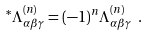Convert formula to latex. <formula><loc_0><loc_0><loc_500><loc_500>^ { * } { \Lambda } _ { { \alpha } { \beta } { \gamma } } ^ { ( n ) } = ( - 1 ) ^ { n } { \Lambda } _ { { \alpha } { \beta } { \gamma } } ^ { ( n ) } \ .</formula> 